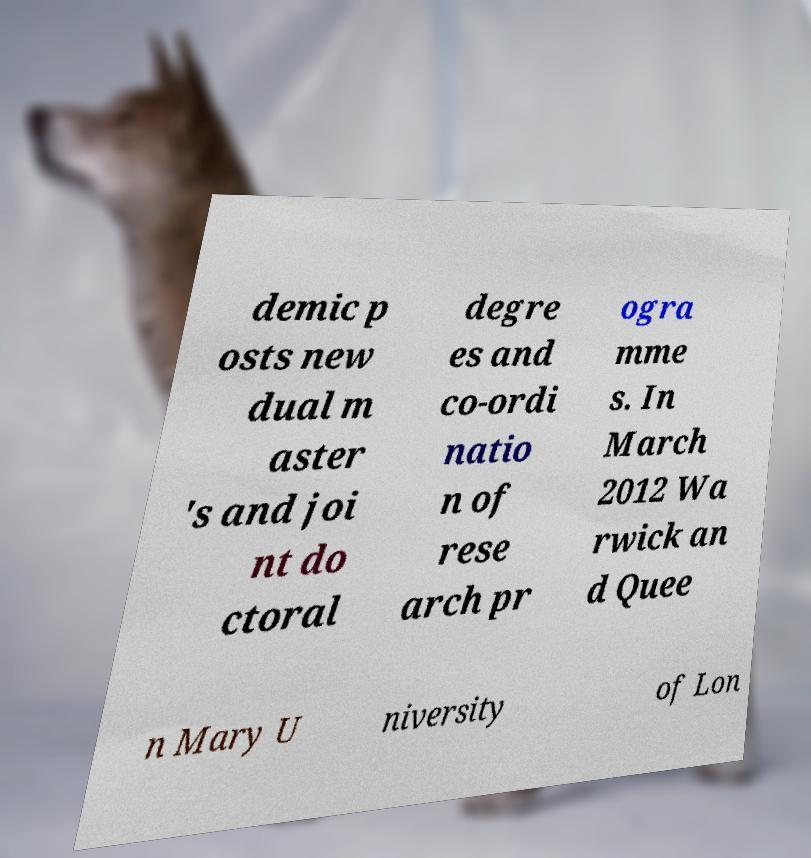Please identify and transcribe the text found in this image. demic p osts new dual m aster 's and joi nt do ctoral degre es and co-ordi natio n of rese arch pr ogra mme s. In March 2012 Wa rwick an d Quee n Mary U niversity of Lon 